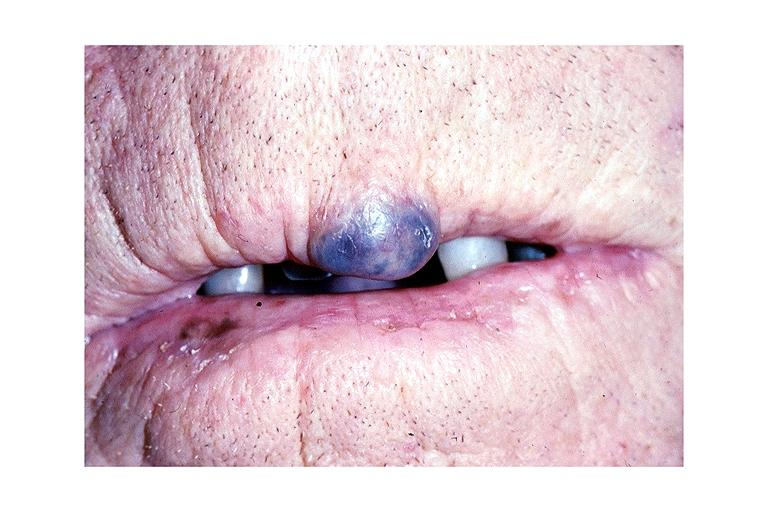s close-up excellent example of interosseous muscle atrophy present?
Answer the question using a single word or phrase. No 